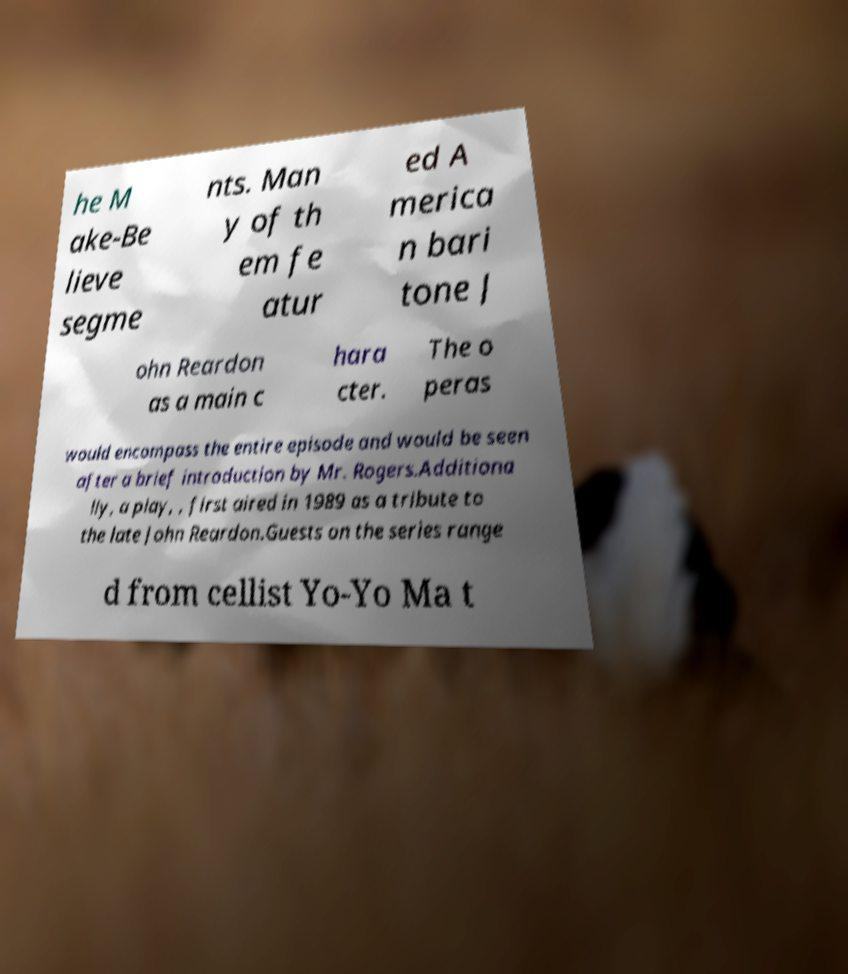There's text embedded in this image that I need extracted. Can you transcribe it verbatim? he M ake-Be lieve segme nts. Man y of th em fe atur ed A merica n bari tone J ohn Reardon as a main c hara cter. The o peras would encompass the entire episode and would be seen after a brief introduction by Mr. Rogers.Additiona lly, a play, , first aired in 1989 as a tribute to the late John Reardon.Guests on the series range d from cellist Yo-Yo Ma t 